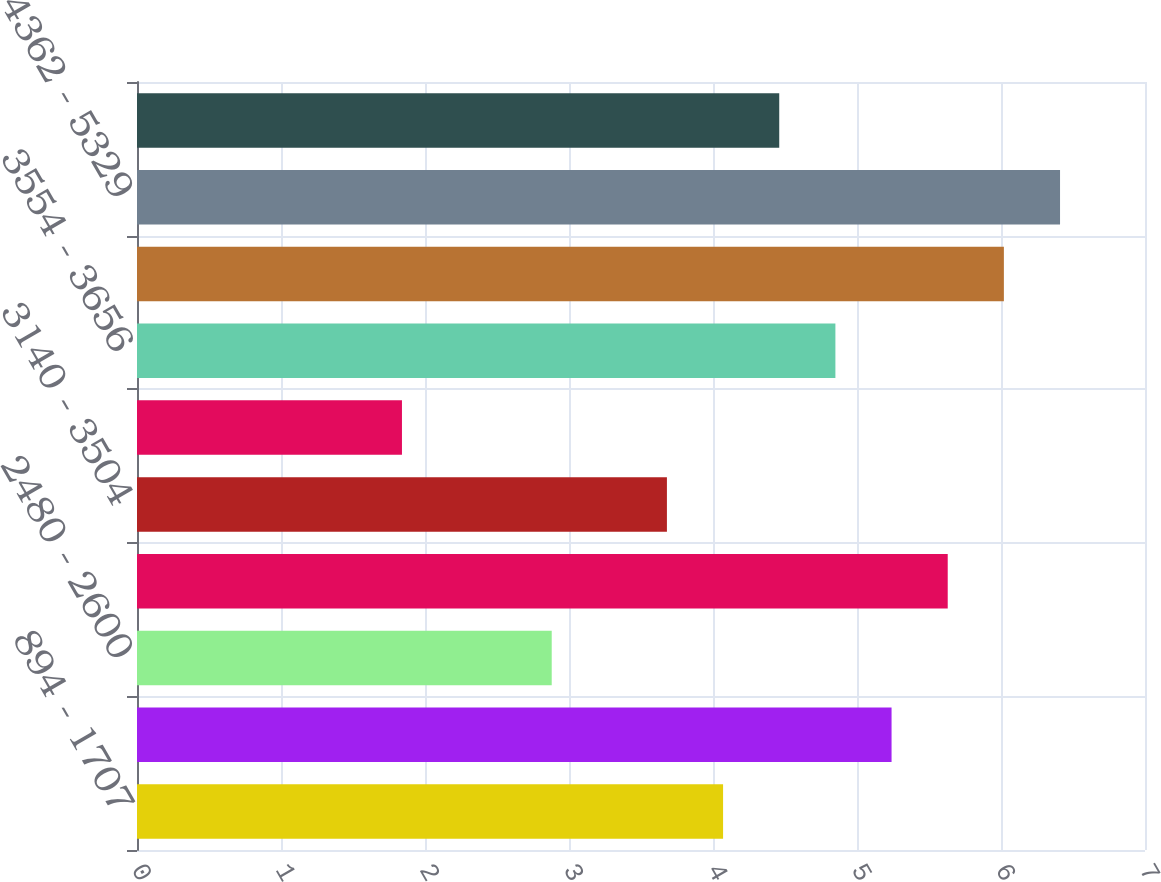<chart> <loc_0><loc_0><loc_500><loc_500><bar_chart><fcel>894 - 1707<fcel>1720 - 2457<fcel>2480 - 2600<fcel>2606 - 3129<fcel>3140 - 3504<fcel>3526 - 3526<fcel>3554 - 3656<fcel>3663 - 4349<fcel>4362 - 5329<fcel>894 - 5330<nl><fcel>4.07<fcel>5.24<fcel>2.88<fcel>5.63<fcel>3.68<fcel>1.84<fcel>4.85<fcel>6.02<fcel>6.41<fcel>4.46<nl></chart> 